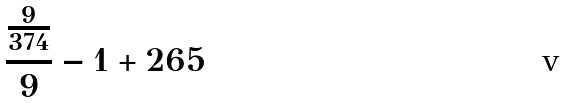<formula> <loc_0><loc_0><loc_500><loc_500>\frac { \frac { 9 } { 3 7 4 } } { 9 } - 1 + 2 6 5</formula> 